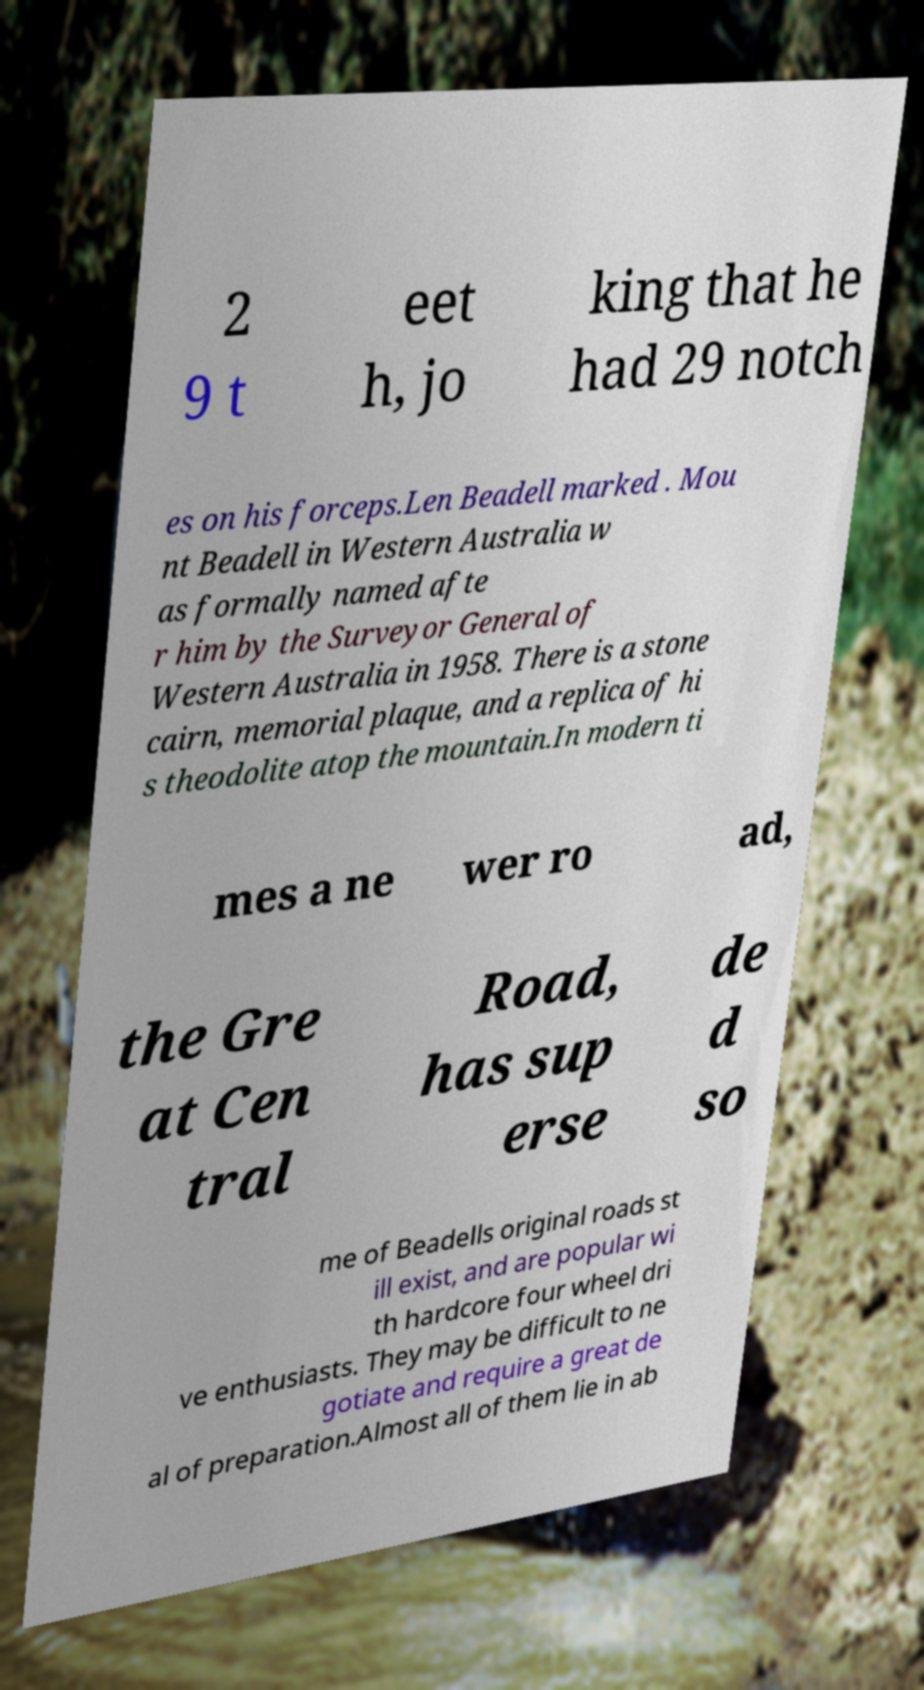Can you read and provide the text displayed in the image?This photo seems to have some interesting text. Can you extract and type it out for me? 2 9 t eet h, jo king that he had 29 notch es on his forceps.Len Beadell marked . Mou nt Beadell in Western Australia w as formally named afte r him by the Surveyor General of Western Australia in 1958. There is a stone cairn, memorial plaque, and a replica of hi s theodolite atop the mountain.In modern ti mes a ne wer ro ad, the Gre at Cen tral Road, has sup erse de d so me of Beadells original roads st ill exist, and are popular wi th hardcore four wheel dri ve enthusiasts. They may be difficult to ne gotiate and require a great de al of preparation.Almost all of them lie in ab 